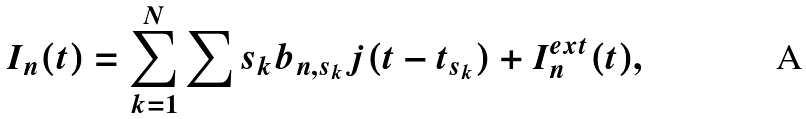Convert formula to latex. <formula><loc_0><loc_0><loc_500><loc_500>I _ { n } ( t ) = \sum _ { k = 1 } ^ { N } \sum { s _ { k } } b _ { n , s _ { k } } j ( t - t _ { s _ { k } } ) + I _ { n } ^ { e x t } ( t ) ,</formula> 